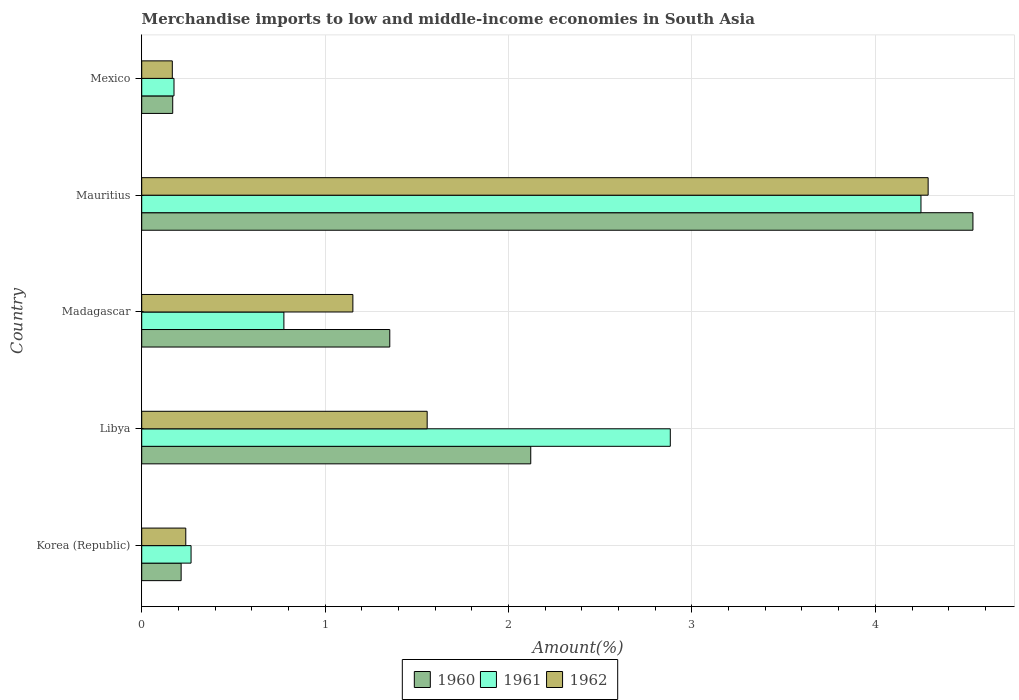How many different coloured bars are there?
Ensure brevity in your answer.  3. What is the label of the 3rd group of bars from the top?
Your answer should be very brief. Madagascar. In how many cases, is the number of bars for a given country not equal to the number of legend labels?
Provide a short and direct response. 0. What is the percentage of amount earned from merchandise imports in 1960 in Mauritius?
Give a very brief answer. 4.53. Across all countries, what is the maximum percentage of amount earned from merchandise imports in 1961?
Offer a terse response. 4.25. Across all countries, what is the minimum percentage of amount earned from merchandise imports in 1962?
Provide a short and direct response. 0.17. In which country was the percentage of amount earned from merchandise imports in 1962 maximum?
Provide a short and direct response. Mauritius. What is the total percentage of amount earned from merchandise imports in 1961 in the graph?
Provide a succinct answer. 8.35. What is the difference between the percentage of amount earned from merchandise imports in 1962 in Korea (Republic) and that in Madagascar?
Offer a very short reply. -0.91. What is the difference between the percentage of amount earned from merchandise imports in 1961 in Madagascar and the percentage of amount earned from merchandise imports in 1960 in Mexico?
Provide a short and direct response. 0.61. What is the average percentage of amount earned from merchandise imports in 1961 per country?
Keep it short and to the point. 1.67. What is the difference between the percentage of amount earned from merchandise imports in 1961 and percentage of amount earned from merchandise imports in 1960 in Mexico?
Your answer should be very brief. 0.01. What is the ratio of the percentage of amount earned from merchandise imports in 1960 in Korea (Republic) to that in Mauritius?
Make the answer very short. 0.05. What is the difference between the highest and the second highest percentage of amount earned from merchandise imports in 1962?
Make the answer very short. 2.73. What is the difference between the highest and the lowest percentage of amount earned from merchandise imports in 1961?
Your answer should be compact. 4.07. Is the sum of the percentage of amount earned from merchandise imports in 1962 in Korea (Republic) and Mauritius greater than the maximum percentage of amount earned from merchandise imports in 1961 across all countries?
Keep it short and to the point. Yes. What does the 3rd bar from the top in Mexico represents?
Your response must be concise. 1960. Is it the case that in every country, the sum of the percentage of amount earned from merchandise imports in 1961 and percentage of amount earned from merchandise imports in 1960 is greater than the percentage of amount earned from merchandise imports in 1962?
Keep it short and to the point. Yes. How many countries are there in the graph?
Offer a terse response. 5. Are the values on the major ticks of X-axis written in scientific E-notation?
Offer a terse response. No. Does the graph contain any zero values?
Your response must be concise. No. Where does the legend appear in the graph?
Your answer should be very brief. Bottom center. How are the legend labels stacked?
Offer a very short reply. Horizontal. What is the title of the graph?
Give a very brief answer. Merchandise imports to low and middle-income economies in South Asia. What is the label or title of the X-axis?
Make the answer very short. Amount(%). What is the Amount(%) in 1960 in Korea (Republic)?
Make the answer very short. 0.21. What is the Amount(%) of 1961 in Korea (Republic)?
Your answer should be very brief. 0.27. What is the Amount(%) in 1962 in Korea (Republic)?
Ensure brevity in your answer.  0.24. What is the Amount(%) of 1960 in Libya?
Your answer should be very brief. 2.12. What is the Amount(%) in 1961 in Libya?
Make the answer very short. 2.88. What is the Amount(%) of 1962 in Libya?
Your response must be concise. 1.56. What is the Amount(%) of 1960 in Madagascar?
Offer a terse response. 1.35. What is the Amount(%) in 1961 in Madagascar?
Offer a very short reply. 0.78. What is the Amount(%) of 1962 in Madagascar?
Offer a terse response. 1.15. What is the Amount(%) of 1960 in Mauritius?
Provide a succinct answer. 4.53. What is the Amount(%) of 1961 in Mauritius?
Give a very brief answer. 4.25. What is the Amount(%) of 1962 in Mauritius?
Ensure brevity in your answer.  4.29. What is the Amount(%) of 1960 in Mexico?
Your answer should be very brief. 0.17. What is the Amount(%) of 1961 in Mexico?
Ensure brevity in your answer.  0.18. What is the Amount(%) in 1962 in Mexico?
Provide a succinct answer. 0.17. Across all countries, what is the maximum Amount(%) of 1960?
Your answer should be compact. 4.53. Across all countries, what is the maximum Amount(%) in 1961?
Keep it short and to the point. 4.25. Across all countries, what is the maximum Amount(%) of 1962?
Provide a succinct answer. 4.29. Across all countries, what is the minimum Amount(%) in 1960?
Your answer should be compact. 0.17. Across all countries, what is the minimum Amount(%) of 1961?
Ensure brevity in your answer.  0.18. Across all countries, what is the minimum Amount(%) of 1962?
Your answer should be compact. 0.17. What is the total Amount(%) in 1960 in the graph?
Your answer should be very brief. 8.39. What is the total Amount(%) in 1961 in the graph?
Make the answer very short. 8.35. What is the total Amount(%) of 1962 in the graph?
Your answer should be very brief. 7.4. What is the difference between the Amount(%) in 1960 in Korea (Republic) and that in Libya?
Offer a terse response. -1.91. What is the difference between the Amount(%) of 1961 in Korea (Republic) and that in Libya?
Offer a very short reply. -2.61. What is the difference between the Amount(%) of 1962 in Korea (Republic) and that in Libya?
Your answer should be compact. -1.32. What is the difference between the Amount(%) of 1960 in Korea (Republic) and that in Madagascar?
Your answer should be very brief. -1.14. What is the difference between the Amount(%) in 1961 in Korea (Republic) and that in Madagascar?
Your response must be concise. -0.51. What is the difference between the Amount(%) of 1962 in Korea (Republic) and that in Madagascar?
Ensure brevity in your answer.  -0.91. What is the difference between the Amount(%) in 1960 in Korea (Republic) and that in Mauritius?
Offer a terse response. -4.32. What is the difference between the Amount(%) of 1961 in Korea (Republic) and that in Mauritius?
Your answer should be very brief. -3.98. What is the difference between the Amount(%) in 1962 in Korea (Republic) and that in Mauritius?
Keep it short and to the point. -4.05. What is the difference between the Amount(%) in 1960 in Korea (Republic) and that in Mexico?
Provide a succinct answer. 0.05. What is the difference between the Amount(%) of 1961 in Korea (Republic) and that in Mexico?
Offer a very short reply. 0.09. What is the difference between the Amount(%) in 1962 in Korea (Republic) and that in Mexico?
Your answer should be compact. 0.07. What is the difference between the Amount(%) of 1960 in Libya and that in Madagascar?
Give a very brief answer. 0.77. What is the difference between the Amount(%) in 1961 in Libya and that in Madagascar?
Provide a succinct answer. 2.11. What is the difference between the Amount(%) in 1962 in Libya and that in Madagascar?
Make the answer very short. 0.41. What is the difference between the Amount(%) of 1960 in Libya and that in Mauritius?
Offer a very short reply. -2.41. What is the difference between the Amount(%) in 1961 in Libya and that in Mauritius?
Provide a short and direct response. -1.37. What is the difference between the Amount(%) in 1962 in Libya and that in Mauritius?
Ensure brevity in your answer.  -2.73. What is the difference between the Amount(%) of 1960 in Libya and that in Mexico?
Your answer should be compact. 1.95. What is the difference between the Amount(%) of 1961 in Libya and that in Mexico?
Offer a very short reply. 2.71. What is the difference between the Amount(%) in 1962 in Libya and that in Mexico?
Ensure brevity in your answer.  1.39. What is the difference between the Amount(%) of 1960 in Madagascar and that in Mauritius?
Provide a succinct answer. -3.18. What is the difference between the Amount(%) of 1961 in Madagascar and that in Mauritius?
Provide a succinct answer. -3.47. What is the difference between the Amount(%) of 1962 in Madagascar and that in Mauritius?
Provide a short and direct response. -3.14. What is the difference between the Amount(%) of 1960 in Madagascar and that in Mexico?
Keep it short and to the point. 1.18. What is the difference between the Amount(%) in 1961 in Madagascar and that in Mexico?
Offer a very short reply. 0.6. What is the difference between the Amount(%) in 1962 in Madagascar and that in Mexico?
Keep it short and to the point. 0.98. What is the difference between the Amount(%) of 1960 in Mauritius and that in Mexico?
Your answer should be very brief. 4.36. What is the difference between the Amount(%) in 1961 in Mauritius and that in Mexico?
Ensure brevity in your answer.  4.07. What is the difference between the Amount(%) of 1962 in Mauritius and that in Mexico?
Your response must be concise. 4.12. What is the difference between the Amount(%) in 1960 in Korea (Republic) and the Amount(%) in 1961 in Libya?
Provide a succinct answer. -2.67. What is the difference between the Amount(%) in 1960 in Korea (Republic) and the Amount(%) in 1962 in Libya?
Your answer should be very brief. -1.34. What is the difference between the Amount(%) in 1961 in Korea (Republic) and the Amount(%) in 1962 in Libya?
Your response must be concise. -1.29. What is the difference between the Amount(%) of 1960 in Korea (Republic) and the Amount(%) of 1961 in Madagascar?
Offer a very short reply. -0.56. What is the difference between the Amount(%) of 1960 in Korea (Republic) and the Amount(%) of 1962 in Madagascar?
Make the answer very short. -0.94. What is the difference between the Amount(%) of 1961 in Korea (Republic) and the Amount(%) of 1962 in Madagascar?
Provide a short and direct response. -0.88. What is the difference between the Amount(%) in 1960 in Korea (Republic) and the Amount(%) in 1961 in Mauritius?
Make the answer very short. -4.03. What is the difference between the Amount(%) in 1960 in Korea (Republic) and the Amount(%) in 1962 in Mauritius?
Provide a short and direct response. -4.07. What is the difference between the Amount(%) in 1961 in Korea (Republic) and the Amount(%) in 1962 in Mauritius?
Provide a succinct answer. -4.02. What is the difference between the Amount(%) in 1960 in Korea (Republic) and the Amount(%) in 1961 in Mexico?
Ensure brevity in your answer.  0.04. What is the difference between the Amount(%) of 1960 in Korea (Republic) and the Amount(%) of 1962 in Mexico?
Give a very brief answer. 0.05. What is the difference between the Amount(%) of 1961 in Korea (Republic) and the Amount(%) of 1962 in Mexico?
Your answer should be very brief. 0.1. What is the difference between the Amount(%) of 1960 in Libya and the Amount(%) of 1961 in Madagascar?
Offer a terse response. 1.35. What is the difference between the Amount(%) of 1960 in Libya and the Amount(%) of 1962 in Madagascar?
Offer a terse response. 0.97. What is the difference between the Amount(%) in 1961 in Libya and the Amount(%) in 1962 in Madagascar?
Your response must be concise. 1.73. What is the difference between the Amount(%) of 1960 in Libya and the Amount(%) of 1961 in Mauritius?
Make the answer very short. -2.13. What is the difference between the Amount(%) of 1960 in Libya and the Amount(%) of 1962 in Mauritius?
Your answer should be compact. -2.17. What is the difference between the Amount(%) in 1961 in Libya and the Amount(%) in 1962 in Mauritius?
Provide a succinct answer. -1.41. What is the difference between the Amount(%) in 1960 in Libya and the Amount(%) in 1961 in Mexico?
Give a very brief answer. 1.95. What is the difference between the Amount(%) of 1960 in Libya and the Amount(%) of 1962 in Mexico?
Offer a very short reply. 1.95. What is the difference between the Amount(%) of 1961 in Libya and the Amount(%) of 1962 in Mexico?
Your answer should be very brief. 2.72. What is the difference between the Amount(%) of 1960 in Madagascar and the Amount(%) of 1961 in Mauritius?
Your response must be concise. -2.9. What is the difference between the Amount(%) in 1960 in Madagascar and the Amount(%) in 1962 in Mauritius?
Your response must be concise. -2.94. What is the difference between the Amount(%) of 1961 in Madagascar and the Amount(%) of 1962 in Mauritius?
Ensure brevity in your answer.  -3.51. What is the difference between the Amount(%) of 1960 in Madagascar and the Amount(%) of 1961 in Mexico?
Make the answer very short. 1.18. What is the difference between the Amount(%) of 1960 in Madagascar and the Amount(%) of 1962 in Mexico?
Offer a terse response. 1.19. What is the difference between the Amount(%) in 1961 in Madagascar and the Amount(%) in 1962 in Mexico?
Give a very brief answer. 0.61. What is the difference between the Amount(%) of 1960 in Mauritius and the Amount(%) of 1961 in Mexico?
Offer a terse response. 4.36. What is the difference between the Amount(%) in 1960 in Mauritius and the Amount(%) in 1962 in Mexico?
Make the answer very short. 4.37. What is the difference between the Amount(%) in 1961 in Mauritius and the Amount(%) in 1962 in Mexico?
Offer a terse response. 4.08. What is the average Amount(%) of 1960 per country?
Your response must be concise. 1.68. What is the average Amount(%) of 1961 per country?
Ensure brevity in your answer.  1.67. What is the average Amount(%) in 1962 per country?
Your response must be concise. 1.48. What is the difference between the Amount(%) of 1960 and Amount(%) of 1961 in Korea (Republic)?
Provide a succinct answer. -0.05. What is the difference between the Amount(%) in 1960 and Amount(%) in 1962 in Korea (Republic)?
Keep it short and to the point. -0.03. What is the difference between the Amount(%) of 1961 and Amount(%) of 1962 in Korea (Republic)?
Offer a very short reply. 0.03. What is the difference between the Amount(%) in 1960 and Amount(%) in 1961 in Libya?
Offer a terse response. -0.76. What is the difference between the Amount(%) of 1960 and Amount(%) of 1962 in Libya?
Your response must be concise. 0.56. What is the difference between the Amount(%) in 1961 and Amount(%) in 1962 in Libya?
Give a very brief answer. 1.33. What is the difference between the Amount(%) of 1960 and Amount(%) of 1961 in Madagascar?
Your answer should be compact. 0.58. What is the difference between the Amount(%) of 1960 and Amount(%) of 1962 in Madagascar?
Keep it short and to the point. 0.2. What is the difference between the Amount(%) of 1961 and Amount(%) of 1962 in Madagascar?
Your answer should be compact. -0.38. What is the difference between the Amount(%) in 1960 and Amount(%) in 1961 in Mauritius?
Your answer should be compact. 0.28. What is the difference between the Amount(%) of 1960 and Amount(%) of 1962 in Mauritius?
Provide a short and direct response. 0.24. What is the difference between the Amount(%) in 1961 and Amount(%) in 1962 in Mauritius?
Keep it short and to the point. -0.04. What is the difference between the Amount(%) in 1960 and Amount(%) in 1961 in Mexico?
Give a very brief answer. -0.01. What is the difference between the Amount(%) of 1960 and Amount(%) of 1962 in Mexico?
Give a very brief answer. 0. What is the difference between the Amount(%) of 1961 and Amount(%) of 1962 in Mexico?
Make the answer very short. 0.01. What is the ratio of the Amount(%) in 1960 in Korea (Republic) to that in Libya?
Your response must be concise. 0.1. What is the ratio of the Amount(%) of 1961 in Korea (Republic) to that in Libya?
Your response must be concise. 0.09. What is the ratio of the Amount(%) in 1962 in Korea (Republic) to that in Libya?
Provide a succinct answer. 0.15. What is the ratio of the Amount(%) of 1960 in Korea (Republic) to that in Madagascar?
Offer a very short reply. 0.16. What is the ratio of the Amount(%) of 1961 in Korea (Republic) to that in Madagascar?
Provide a short and direct response. 0.35. What is the ratio of the Amount(%) in 1962 in Korea (Republic) to that in Madagascar?
Keep it short and to the point. 0.21. What is the ratio of the Amount(%) in 1960 in Korea (Republic) to that in Mauritius?
Provide a short and direct response. 0.05. What is the ratio of the Amount(%) in 1961 in Korea (Republic) to that in Mauritius?
Your answer should be very brief. 0.06. What is the ratio of the Amount(%) of 1962 in Korea (Republic) to that in Mauritius?
Offer a terse response. 0.06. What is the ratio of the Amount(%) of 1960 in Korea (Republic) to that in Mexico?
Your response must be concise. 1.27. What is the ratio of the Amount(%) of 1961 in Korea (Republic) to that in Mexico?
Provide a short and direct response. 1.53. What is the ratio of the Amount(%) of 1962 in Korea (Republic) to that in Mexico?
Offer a very short reply. 1.44. What is the ratio of the Amount(%) of 1960 in Libya to that in Madagascar?
Ensure brevity in your answer.  1.57. What is the ratio of the Amount(%) of 1961 in Libya to that in Madagascar?
Keep it short and to the point. 3.72. What is the ratio of the Amount(%) of 1962 in Libya to that in Madagascar?
Your answer should be very brief. 1.35. What is the ratio of the Amount(%) in 1960 in Libya to that in Mauritius?
Give a very brief answer. 0.47. What is the ratio of the Amount(%) in 1961 in Libya to that in Mauritius?
Provide a short and direct response. 0.68. What is the ratio of the Amount(%) of 1962 in Libya to that in Mauritius?
Ensure brevity in your answer.  0.36. What is the ratio of the Amount(%) of 1960 in Libya to that in Mexico?
Provide a succinct answer. 12.55. What is the ratio of the Amount(%) of 1961 in Libya to that in Mexico?
Keep it short and to the point. 16.37. What is the ratio of the Amount(%) in 1962 in Libya to that in Mexico?
Provide a succinct answer. 9.33. What is the ratio of the Amount(%) of 1960 in Madagascar to that in Mauritius?
Give a very brief answer. 0.3. What is the ratio of the Amount(%) of 1961 in Madagascar to that in Mauritius?
Provide a succinct answer. 0.18. What is the ratio of the Amount(%) in 1962 in Madagascar to that in Mauritius?
Ensure brevity in your answer.  0.27. What is the ratio of the Amount(%) of 1960 in Madagascar to that in Mexico?
Your response must be concise. 8. What is the ratio of the Amount(%) in 1961 in Madagascar to that in Mexico?
Make the answer very short. 4.4. What is the ratio of the Amount(%) of 1962 in Madagascar to that in Mexico?
Your answer should be very brief. 6.9. What is the ratio of the Amount(%) of 1960 in Mauritius to that in Mexico?
Your answer should be compact. 26.81. What is the ratio of the Amount(%) of 1961 in Mauritius to that in Mexico?
Provide a succinct answer. 24.14. What is the ratio of the Amount(%) of 1962 in Mauritius to that in Mexico?
Your response must be concise. 25.7. What is the difference between the highest and the second highest Amount(%) of 1960?
Make the answer very short. 2.41. What is the difference between the highest and the second highest Amount(%) in 1961?
Your answer should be very brief. 1.37. What is the difference between the highest and the second highest Amount(%) in 1962?
Ensure brevity in your answer.  2.73. What is the difference between the highest and the lowest Amount(%) in 1960?
Your response must be concise. 4.36. What is the difference between the highest and the lowest Amount(%) in 1961?
Keep it short and to the point. 4.07. What is the difference between the highest and the lowest Amount(%) in 1962?
Ensure brevity in your answer.  4.12. 